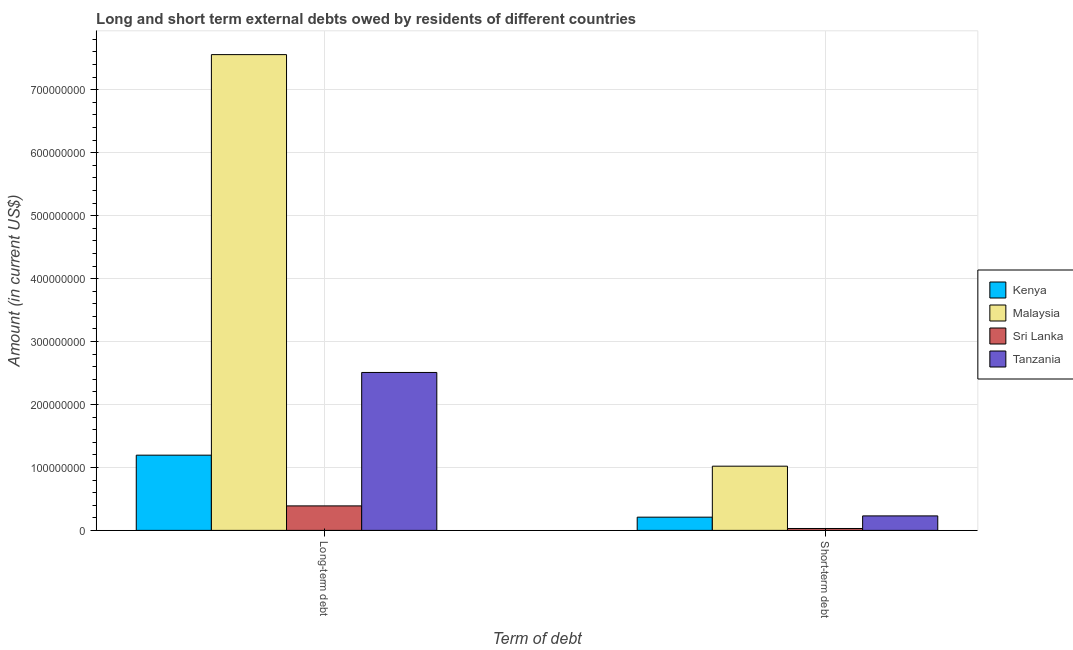How many groups of bars are there?
Your answer should be very brief. 2. Are the number of bars per tick equal to the number of legend labels?
Your answer should be compact. Yes. How many bars are there on the 2nd tick from the left?
Your answer should be compact. 4. How many bars are there on the 1st tick from the right?
Provide a succinct answer. 4. What is the label of the 1st group of bars from the left?
Your answer should be compact. Long-term debt. What is the short-term debts owed by residents in Tanzania?
Provide a succinct answer. 2.30e+07. Across all countries, what is the maximum long-term debts owed by residents?
Keep it short and to the point. 7.56e+08. Across all countries, what is the minimum short-term debts owed by residents?
Your answer should be compact. 3.00e+06. In which country was the long-term debts owed by residents maximum?
Your answer should be very brief. Malaysia. In which country was the long-term debts owed by residents minimum?
Give a very brief answer. Sri Lanka. What is the total short-term debts owed by residents in the graph?
Your response must be concise. 1.49e+08. What is the difference between the short-term debts owed by residents in Kenya and that in Malaysia?
Offer a very short reply. -8.10e+07. What is the difference between the short-term debts owed by residents in Tanzania and the long-term debts owed by residents in Malaysia?
Your answer should be compact. -7.33e+08. What is the average short-term debts owed by residents per country?
Offer a terse response. 3.72e+07. What is the difference between the short-term debts owed by residents and long-term debts owed by residents in Tanzania?
Provide a succinct answer. -2.28e+08. In how many countries, is the short-term debts owed by residents greater than 160000000 US$?
Your answer should be very brief. 0. What is the ratio of the long-term debts owed by residents in Malaysia to that in Sri Lanka?
Your answer should be compact. 19.44. Is the short-term debts owed by residents in Tanzania less than that in Malaysia?
Make the answer very short. Yes. In how many countries, is the short-term debts owed by residents greater than the average short-term debts owed by residents taken over all countries?
Make the answer very short. 1. What does the 1st bar from the left in Short-term debt represents?
Your answer should be compact. Kenya. What does the 3rd bar from the right in Short-term debt represents?
Provide a short and direct response. Malaysia. How many countries are there in the graph?
Offer a terse response. 4. Are the values on the major ticks of Y-axis written in scientific E-notation?
Provide a short and direct response. No. Does the graph contain any zero values?
Offer a terse response. No. How are the legend labels stacked?
Keep it short and to the point. Vertical. What is the title of the graph?
Keep it short and to the point. Long and short term external debts owed by residents of different countries. What is the label or title of the X-axis?
Provide a short and direct response. Term of debt. What is the label or title of the Y-axis?
Your answer should be very brief. Amount (in current US$). What is the Amount (in current US$) of Kenya in Long-term debt?
Give a very brief answer. 1.19e+08. What is the Amount (in current US$) in Malaysia in Long-term debt?
Your answer should be compact. 7.56e+08. What is the Amount (in current US$) in Sri Lanka in Long-term debt?
Keep it short and to the point. 3.89e+07. What is the Amount (in current US$) in Tanzania in Long-term debt?
Offer a terse response. 2.51e+08. What is the Amount (in current US$) in Kenya in Short-term debt?
Give a very brief answer. 2.10e+07. What is the Amount (in current US$) of Malaysia in Short-term debt?
Your answer should be compact. 1.02e+08. What is the Amount (in current US$) in Tanzania in Short-term debt?
Provide a succinct answer. 2.30e+07. Across all Term of debt, what is the maximum Amount (in current US$) of Kenya?
Keep it short and to the point. 1.19e+08. Across all Term of debt, what is the maximum Amount (in current US$) of Malaysia?
Offer a very short reply. 7.56e+08. Across all Term of debt, what is the maximum Amount (in current US$) in Sri Lanka?
Ensure brevity in your answer.  3.89e+07. Across all Term of debt, what is the maximum Amount (in current US$) in Tanzania?
Give a very brief answer. 2.51e+08. Across all Term of debt, what is the minimum Amount (in current US$) of Kenya?
Your answer should be very brief. 2.10e+07. Across all Term of debt, what is the minimum Amount (in current US$) of Malaysia?
Your answer should be compact. 1.02e+08. Across all Term of debt, what is the minimum Amount (in current US$) of Sri Lanka?
Provide a succinct answer. 3.00e+06. Across all Term of debt, what is the minimum Amount (in current US$) in Tanzania?
Ensure brevity in your answer.  2.30e+07. What is the total Amount (in current US$) of Kenya in the graph?
Offer a very short reply. 1.40e+08. What is the total Amount (in current US$) of Malaysia in the graph?
Your answer should be very brief. 8.58e+08. What is the total Amount (in current US$) in Sri Lanka in the graph?
Offer a very short reply. 4.19e+07. What is the total Amount (in current US$) in Tanzania in the graph?
Offer a terse response. 2.74e+08. What is the difference between the Amount (in current US$) of Kenya in Long-term debt and that in Short-term debt?
Make the answer very short. 9.85e+07. What is the difference between the Amount (in current US$) of Malaysia in Long-term debt and that in Short-term debt?
Your response must be concise. 6.54e+08. What is the difference between the Amount (in current US$) in Sri Lanka in Long-term debt and that in Short-term debt?
Provide a short and direct response. 3.59e+07. What is the difference between the Amount (in current US$) in Tanzania in Long-term debt and that in Short-term debt?
Keep it short and to the point. 2.28e+08. What is the difference between the Amount (in current US$) in Kenya in Long-term debt and the Amount (in current US$) in Malaysia in Short-term debt?
Your answer should be compact. 1.75e+07. What is the difference between the Amount (in current US$) of Kenya in Long-term debt and the Amount (in current US$) of Sri Lanka in Short-term debt?
Offer a terse response. 1.16e+08. What is the difference between the Amount (in current US$) in Kenya in Long-term debt and the Amount (in current US$) in Tanzania in Short-term debt?
Keep it short and to the point. 9.65e+07. What is the difference between the Amount (in current US$) in Malaysia in Long-term debt and the Amount (in current US$) in Sri Lanka in Short-term debt?
Ensure brevity in your answer.  7.53e+08. What is the difference between the Amount (in current US$) in Malaysia in Long-term debt and the Amount (in current US$) in Tanzania in Short-term debt?
Your answer should be compact. 7.33e+08. What is the difference between the Amount (in current US$) of Sri Lanka in Long-term debt and the Amount (in current US$) of Tanzania in Short-term debt?
Keep it short and to the point. 1.59e+07. What is the average Amount (in current US$) of Kenya per Term of debt?
Give a very brief answer. 7.02e+07. What is the average Amount (in current US$) in Malaysia per Term of debt?
Keep it short and to the point. 4.29e+08. What is the average Amount (in current US$) of Sri Lanka per Term of debt?
Make the answer very short. 2.09e+07. What is the average Amount (in current US$) in Tanzania per Term of debt?
Your answer should be compact. 1.37e+08. What is the difference between the Amount (in current US$) of Kenya and Amount (in current US$) of Malaysia in Long-term debt?
Keep it short and to the point. -6.36e+08. What is the difference between the Amount (in current US$) of Kenya and Amount (in current US$) of Sri Lanka in Long-term debt?
Your response must be concise. 8.06e+07. What is the difference between the Amount (in current US$) of Kenya and Amount (in current US$) of Tanzania in Long-term debt?
Make the answer very short. -1.31e+08. What is the difference between the Amount (in current US$) in Malaysia and Amount (in current US$) in Sri Lanka in Long-term debt?
Your response must be concise. 7.17e+08. What is the difference between the Amount (in current US$) of Malaysia and Amount (in current US$) of Tanzania in Long-term debt?
Provide a succinct answer. 5.05e+08. What is the difference between the Amount (in current US$) of Sri Lanka and Amount (in current US$) of Tanzania in Long-term debt?
Your response must be concise. -2.12e+08. What is the difference between the Amount (in current US$) in Kenya and Amount (in current US$) in Malaysia in Short-term debt?
Your response must be concise. -8.10e+07. What is the difference between the Amount (in current US$) of Kenya and Amount (in current US$) of Sri Lanka in Short-term debt?
Give a very brief answer. 1.80e+07. What is the difference between the Amount (in current US$) of Kenya and Amount (in current US$) of Tanzania in Short-term debt?
Keep it short and to the point. -2.00e+06. What is the difference between the Amount (in current US$) in Malaysia and Amount (in current US$) in Sri Lanka in Short-term debt?
Keep it short and to the point. 9.90e+07. What is the difference between the Amount (in current US$) of Malaysia and Amount (in current US$) of Tanzania in Short-term debt?
Make the answer very short. 7.90e+07. What is the difference between the Amount (in current US$) of Sri Lanka and Amount (in current US$) of Tanzania in Short-term debt?
Offer a terse response. -2.00e+07. What is the ratio of the Amount (in current US$) of Kenya in Long-term debt to that in Short-term debt?
Keep it short and to the point. 5.69. What is the ratio of the Amount (in current US$) in Malaysia in Long-term debt to that in Short-term debt?
Your answer should be very brief. 7.41. What is the ratio of the Amount (in current US$) in Sri Lanka in Long-term debt to that in Short-term debt?
Give a very brief answer. 12.96. What is the ratio of the Amount (in current US$) in Tanzania in Long-term debt to that in Short-term debt?
Offer a terse response. 10.91. What is the difference between the highest and the second highest Amount (in current US$) in Kenya?
Your answer should be compact. 9.85e+07. What is the difference between the highest and the second highest Amount (in current US$) of Malaysia?
Offer a terse response. 6.54e+08. What is the difference between the highest and the second highest Amount (in current US$) in Sri Lanka?
Your answer should be very brief. 3.59e+07. What is the difference between the highest and the second highest Amount (in current US$) in Tanzania?
Ensure brevity in your answer.  2.28e+08. What is the difference between the highest and the lowest Amount (in current US$) in Kenya?
Provide a succinct answer. 9.85e+07. What is the difference between the highest and the lowest Amount (in current US$) of Malaysia?
Provide a short and direct response. 6.54e+08. What is the difference between the highest and the lowest Amount (in current US$) of Sri Lanka?
Give a very brief answer. 3.59e+07. What is the difference between the highest and the lowest Amount (in current US$) in Tanzania?
Provide a short and direct response. 2.28e+08. 